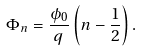<formula> <loc_0><loc_0><loc_500><loc_500>\Phi _ { n } = \frac { \phi _ { 0 } } { q } \left ( n - \frac { 1 } { 2 } \right ) .</formula> 